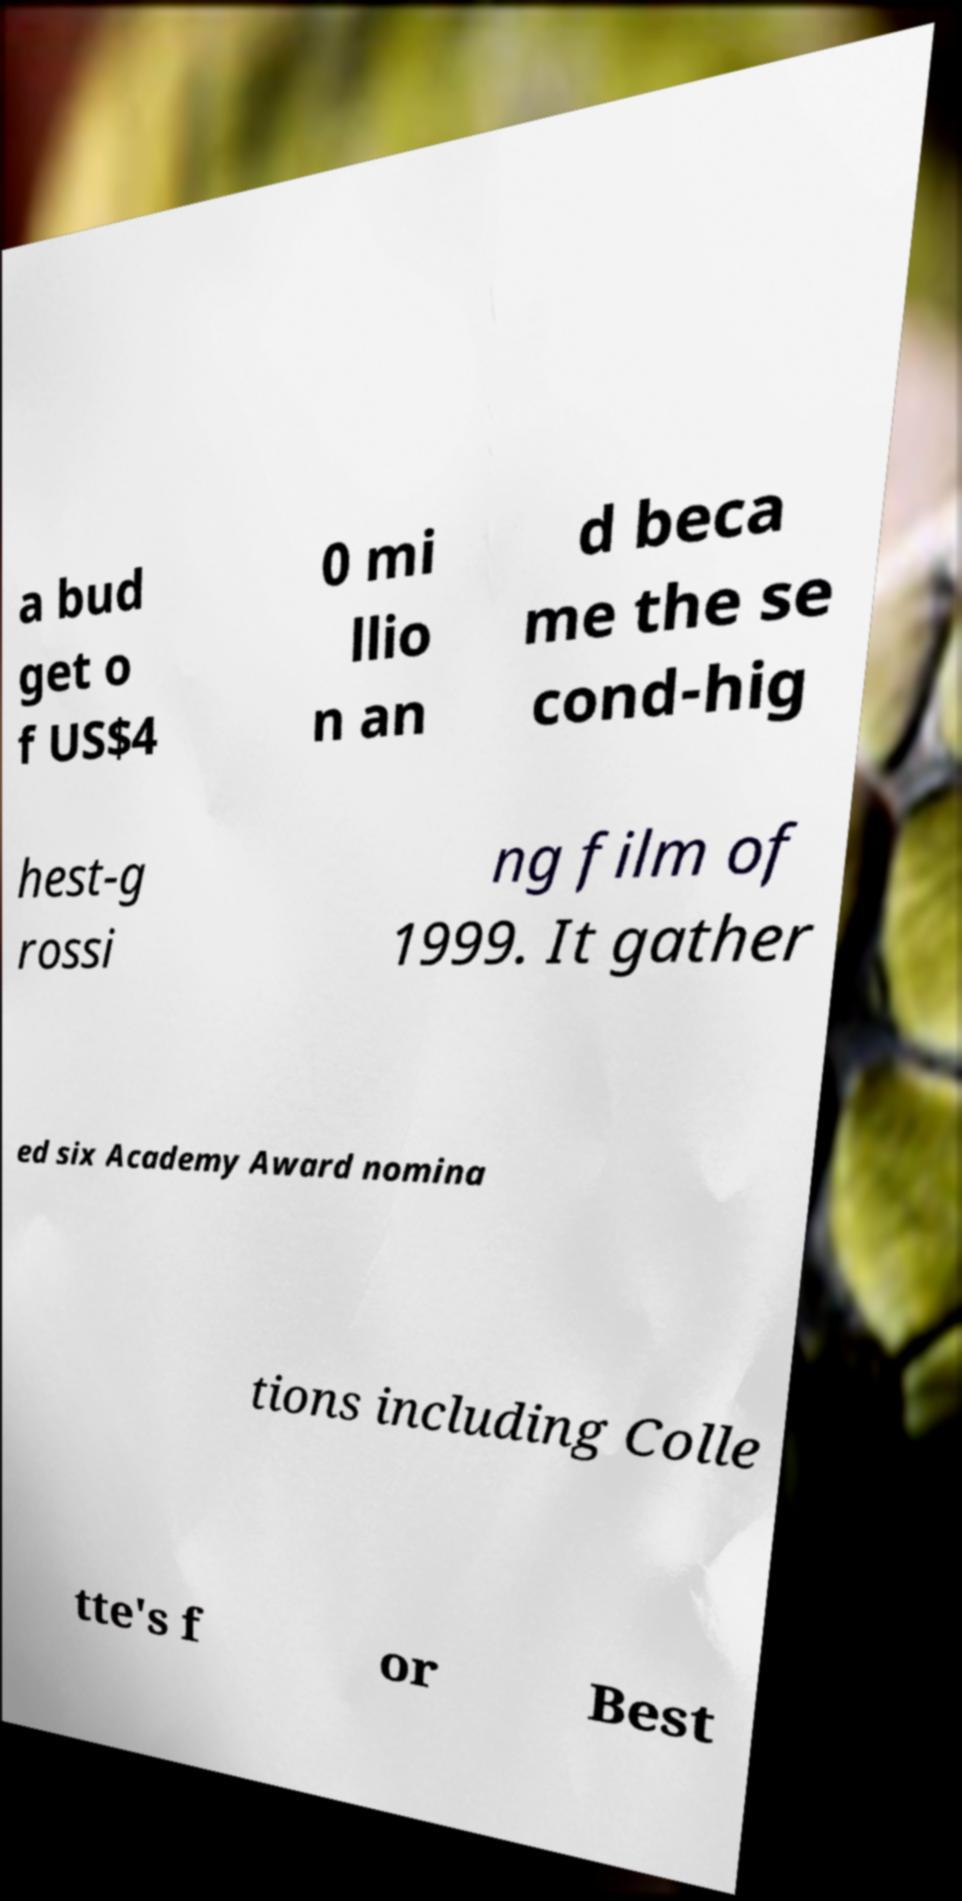I need the written content from this picture converted into text. Can you do that? a bud get o f US$4 0 mi llio n an d beca me the se cond-hig hest-g rossi ng film of 1999. It gather ed six Academy Award nomina tions including Colle tte's f or Best 